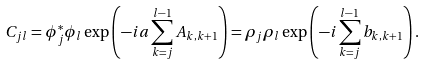<formula> <loc_0><loc_0><loc_500><loc_500>C _ { j l } = \phi ^ { * } _ { j } \phi _ { l } \exp \left ( - i a \sum _ { k = j } ^ { l - 1 } A _ { k , k + 1 } \right ) = \rho _ { j } \rho _ { l } \exp \left ( - i \sum _ { k = j } ^ { l - 1 } b _ { k , k + 1 } \right ) .</formula> 